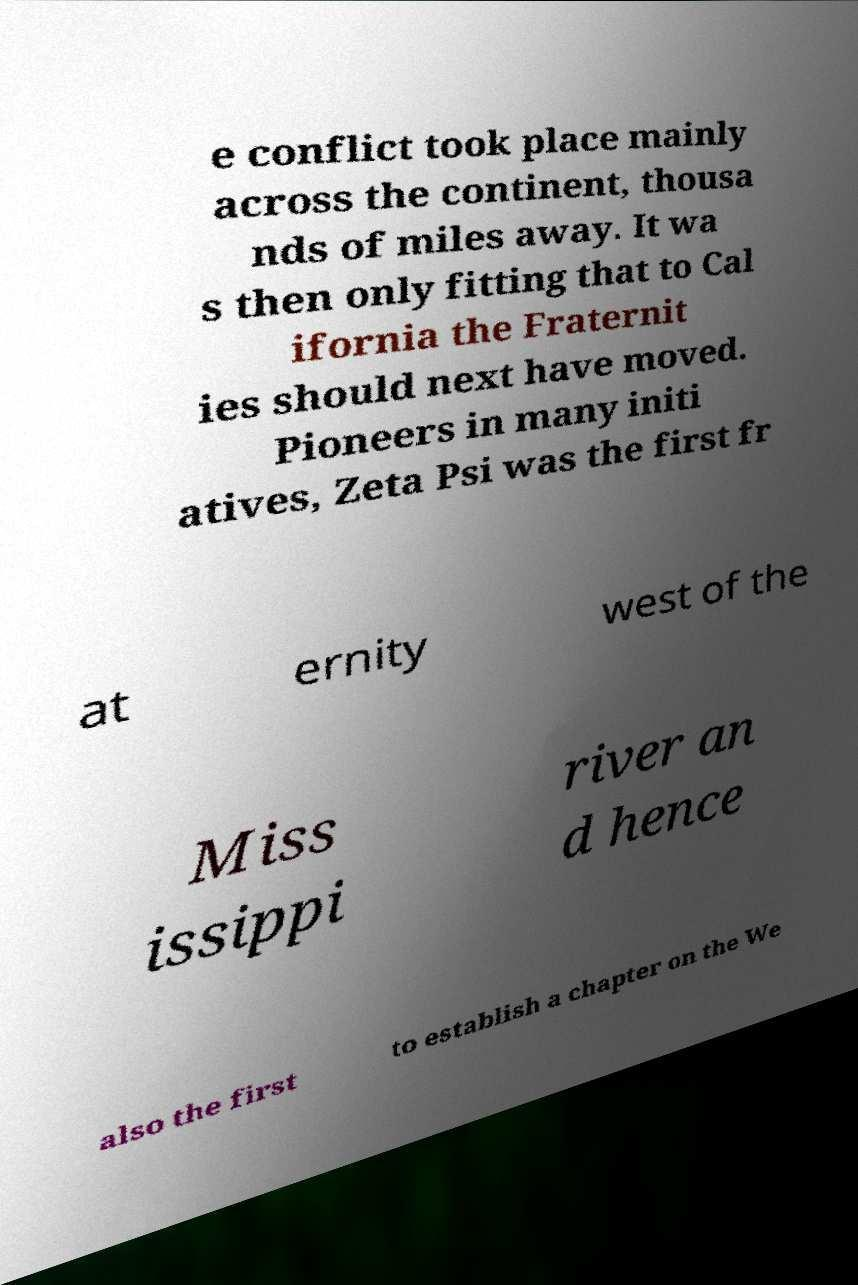There's text embedded in this image that I need extracted. Can you transcribe it verbatim? e conflict took place mainly across the continent, thousa nds of miles away. It wa s then only fitting that to Cal ifornia the Fraternit ies should next have moved. Pioneers in many initi atives, Zeta Psi was the first fr at ernity west of the Miss issippi river an d hence also the first to establish a chapter on the We 